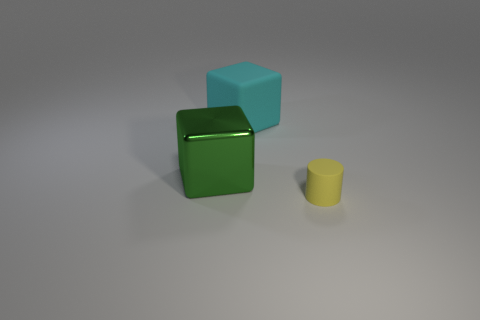What number of things are big green metal blocks or things right of the large green thing?
Provide a succinct answer. 3. What is the shape of the thing that is to the left of the matte cylinder and on the right side of the big metal cube?
Keep it short and to the point. Cube. There is a large thing that is left of the rubber thing that is to the left of the tiny object; what is it made of?
Keep it short and to the point. Metal. Is the big cube that is to the left of the large cyan cube made of the same material as the small thing?
Offer a very short reply. No. How big is the matte object behind the green metallic block?
Offer a terse response. Large. There is a matte thing to the left of the tiny yellow object; is there a big shiny block that is to the right of it?
Your answer should be compact. No. The cylinder is what color?
Your response must be concise. Yellow. Are there any other things that are the same color as the big rubber block?
Offer a terse response. No. There is a object that is both on the right side of the green block and behind the small matte thing; what is its color?
Your response must be concise. Cyan. Does the thing behind the metal object have the same size as the green metallic block?
Provide a succinct answer. Yes. 